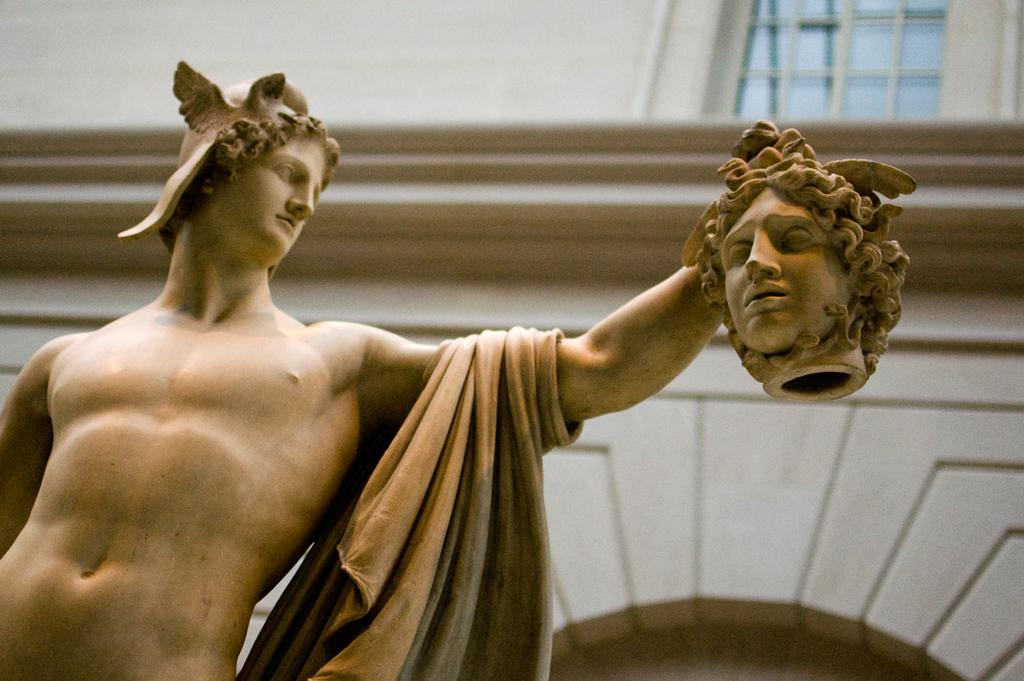What is the main subject in the image? There is a sculpture in the image. Can you describe the setting in which the sculpture is located? There is a building in the background of the image. How many people are taking a trip with the sculpture in the image? There is no indication in the image that people are taking a trip with the sculpture. 